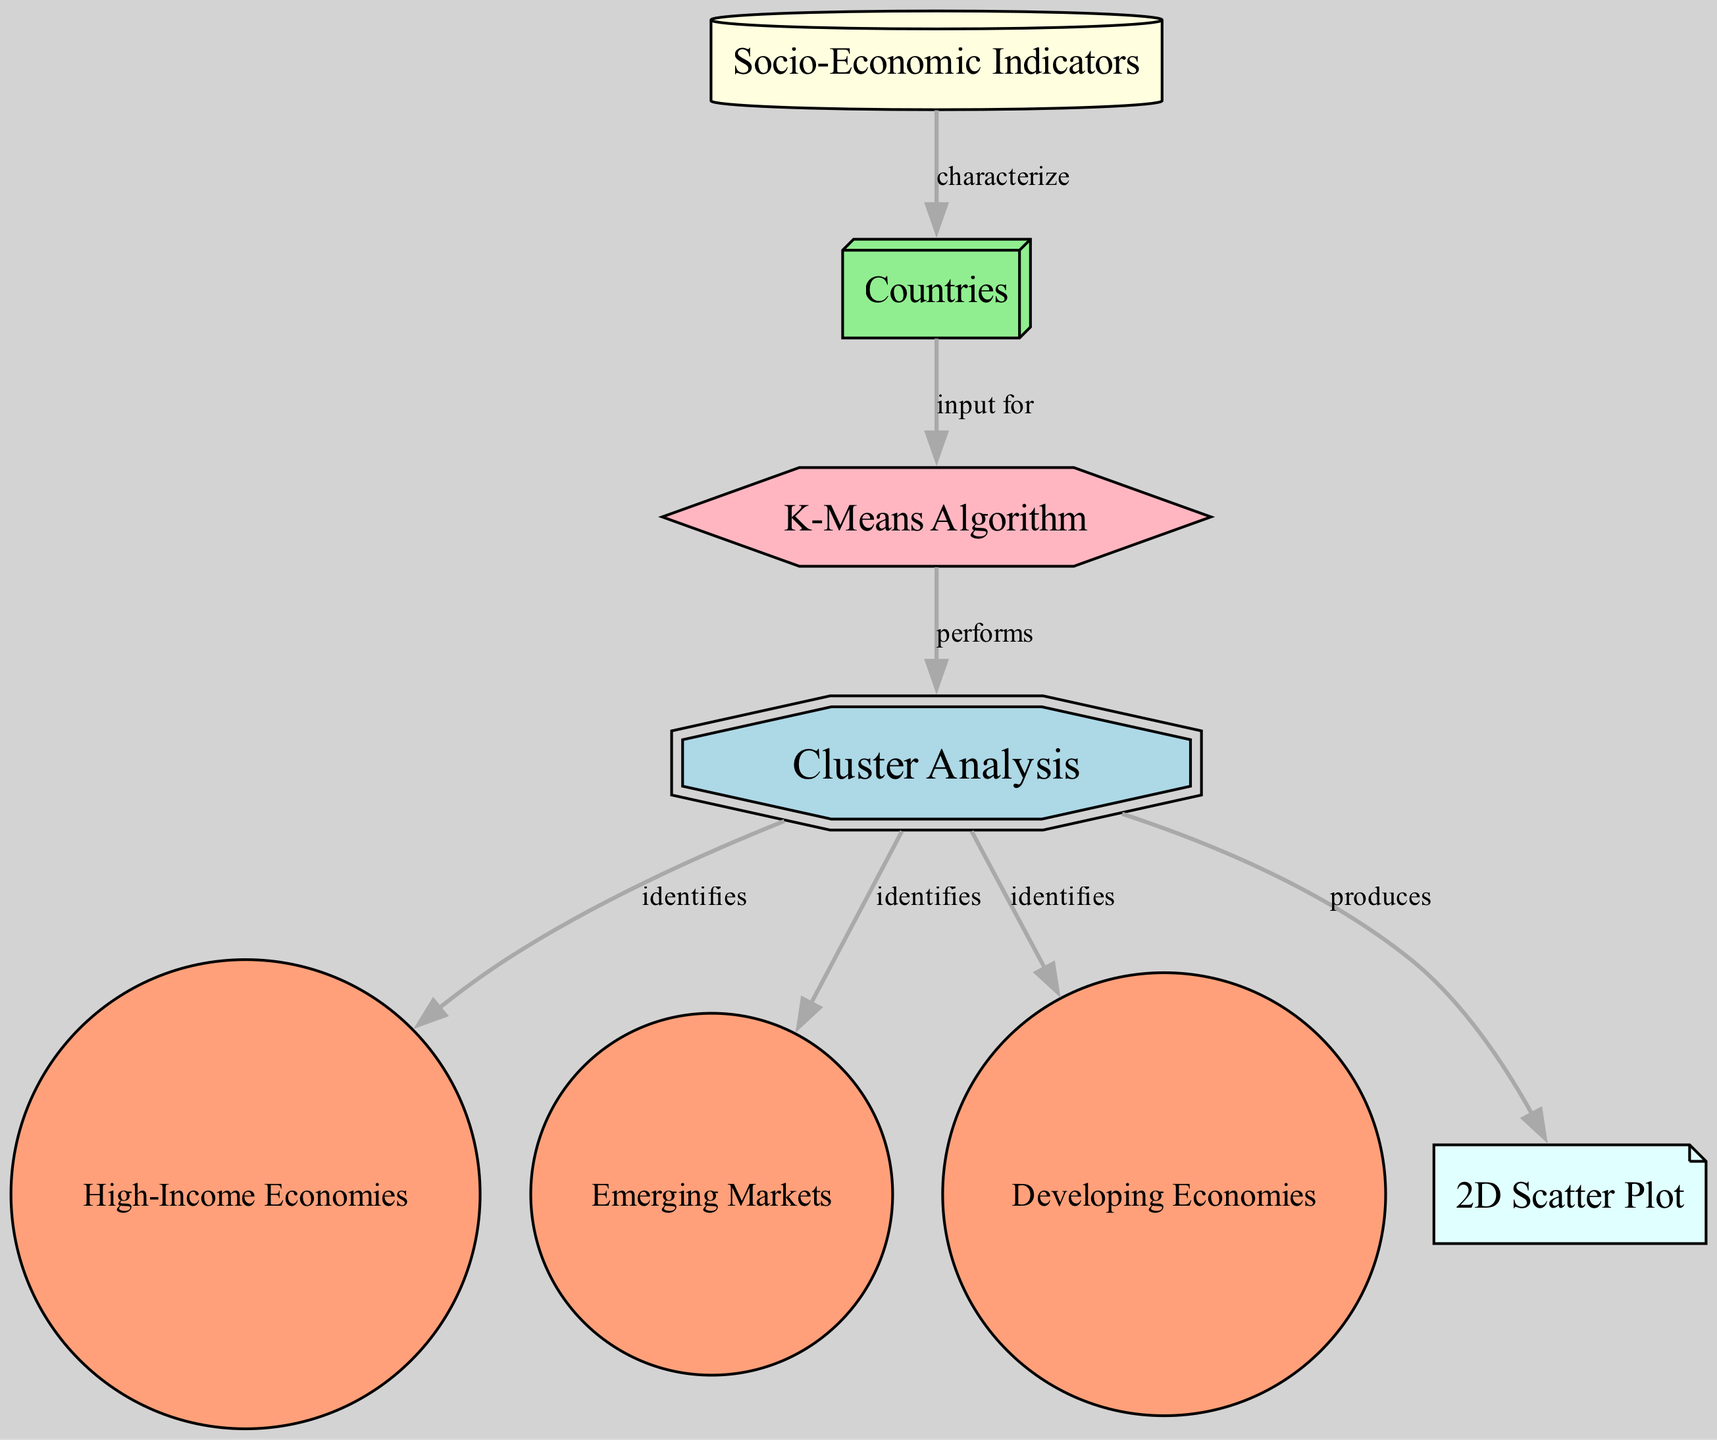What is the main concept illustrated in the diagram? The main concept illustrated in the diagram is located in the node labeled "Cluster Analysis," which signifies the focus of the entire diagram on grouping countries based on various socio-economic indicators.
Answer: Cluster Analysis What algorithm is used for the clustering in this diagram? The diagram indicates the use of the "K-Means Algorithm" as a machine learning algorithm to perform the clustering of countries based on socio-economic indicators.
Answer: K-Means Algorithm How many clusters are identified in the analysis? The diagram shows three clusters identified, which are labeled as "High-Income Economies," "Emerging Markets," and "Developing Economies."
Answer: Three Which type of model output is produced by the cluster analysis? The output produced by the "Cluster Analysis" as indicated in the diagram is a "2D Scatter Plot," which visualizes the clustered groups of countries.
Answer: 2D Scatter Plot What do the socio-economic indicators characterize in the analysis? The socio-economic indicators, as represented in the diagram, characterize the "Countries," serving as the data points for clustering.
Answer: Countries Which cluster is associated with high-income economies? The cluster associated with high-income economies is labeled "High-Income Economies" in the diagram, indicating a specific group of countries classified in that category.
Answer: High-Income Economies What is the relationship between countries and the K-Means algorithm? The relationship is that the "Countries" serve as the input for the "K-Means Algorithm," as indicated by the directed edge connecting these two nodes in the diagram.
Answer: Input for Which clusters does the cluster analysis identify apart from high-income economies? Apart from high-income economies, the cluster analysis also identifies "Emerging Markets" and "Developing Economies," which are explicitly shown as separate clusters in the diagram.
Answer: Emerging Markets and Developing Economies 